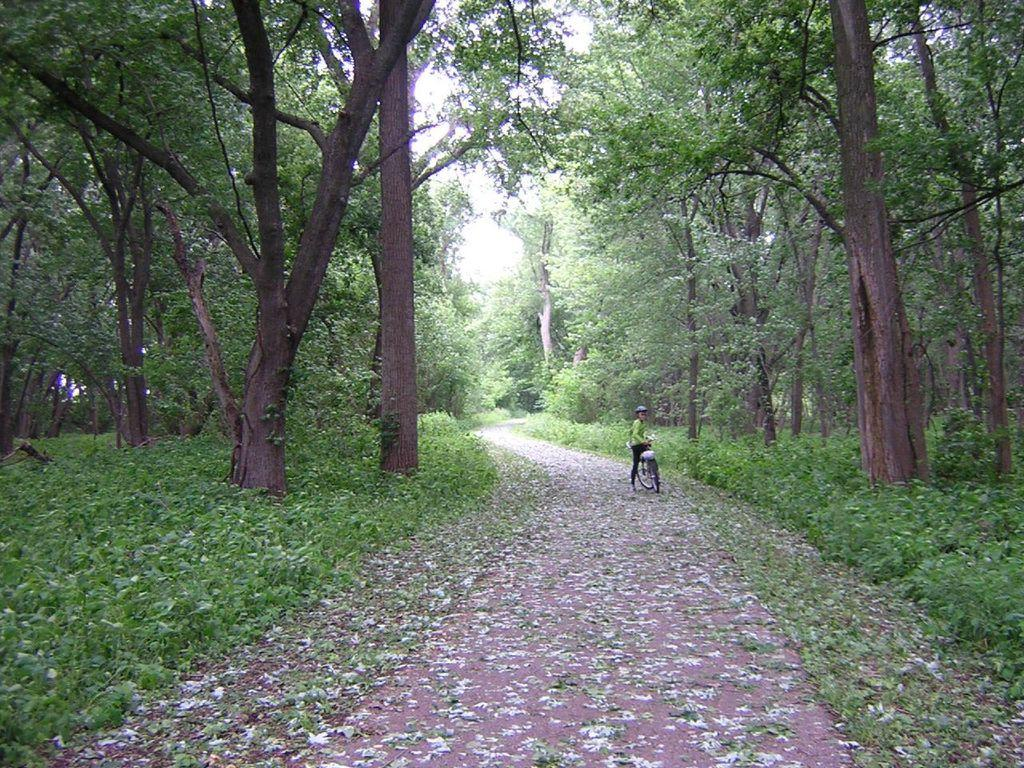What is the main subject of the image? There is a person standing in the image. What is the person wearing? The person is wearing clothes and a helmet. What is the person holding? The person is holding a bicycle. What can be seen in the background of the image? There is a path, grass, trees, and the sky visible in the image. What type of terrain is visible in the image? The terrain includes grass and trees. What book is the person reading while riding the bicycle in the image? There is no book present in the image, and the person is not riding the bicycle. 